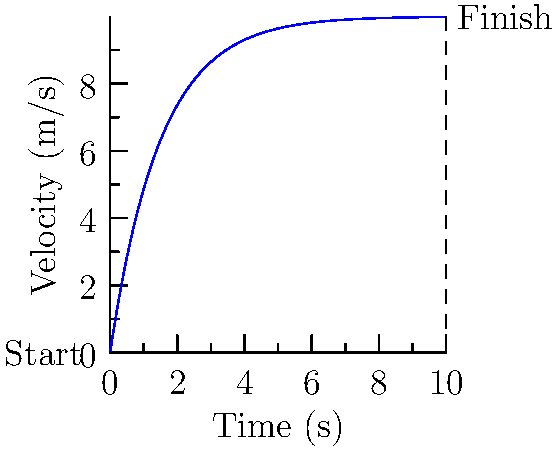As a sprinter, you're analyzing your acceleration curve from the starting blocks to the finish line of a 100m race. The graph shows your velocity over time. At what point in the race do you reach your maximum acceleration? To determine the point of maximum acceleration, we need to analyze the velocity-time curve:

1. Acceleration is the rate of change of velocity with respect to time, which is represented by the slope of the velocity-time curve.

2. The curve starts with a steep slope, indicating rapid acceleration from the starting blocks.

3. As time progresses, the slope of the curve decreases, showing that the rate of acceleration is reducing.

4. The point of maximum acceleration occurs where the slope of the velocity-time curve is steepest.

5. This point is at the very beginning of the race, just as you leave the starting blocks.

6. After this initial burst, your acceleration gradually decreases as you approach your maximum velocity.

7. The curve eventually flattens out, indicating you've reached your top speed and acceleration has reduced to near zero.

Therefore, the maximum acceleration occurs at the start of the race, immediately after leaving the blocks.
Answer: At the start, immediately after leaving the blocks. 